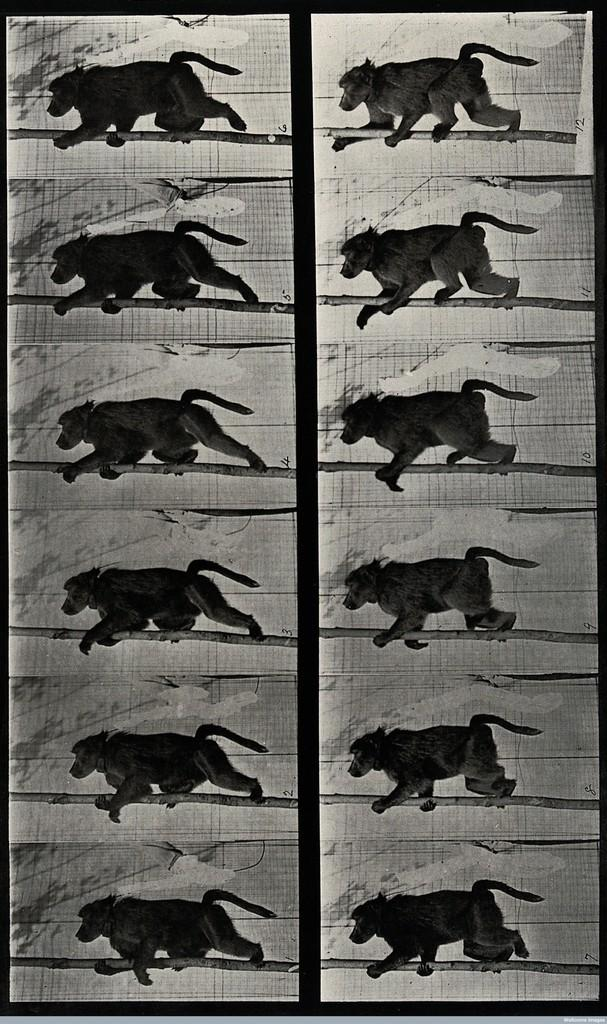What is the main subject of the image? There is an animation of an animal in the image. What type of coal is being used to level the salt in the image? There is no coal or salt present in the image; it features an animation of an animal. 